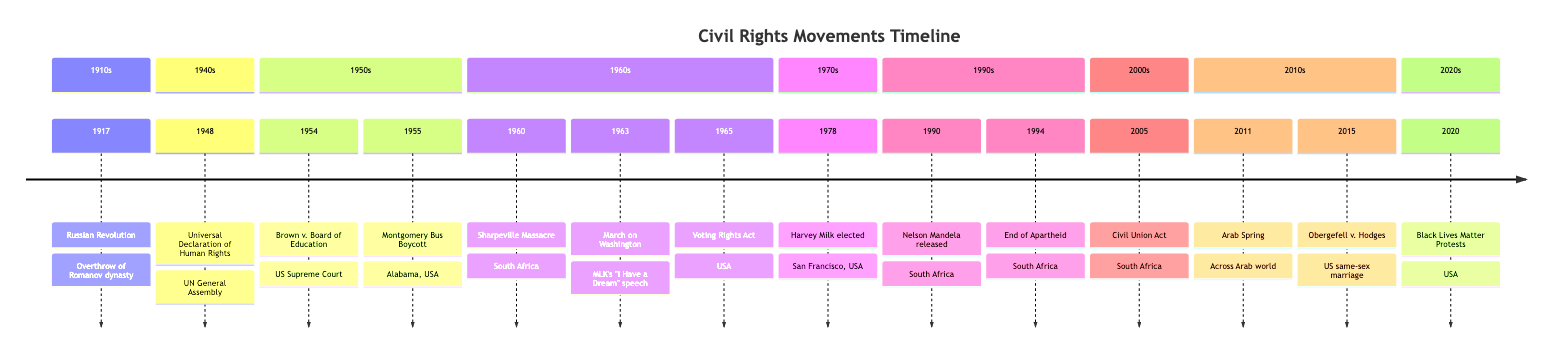What event occurred in 1963? Referring to the timeline, there is a specific node indicating the year 1963, which lists the event "March on Washington for Jobs and Freedom."
Answer: March on Washington for Jobs and Freedom How many major events occurred in the 1950s? By examining the timeline, we can count the events listed under the 1950s section: there are two events, "Brown v. Board of Education" (1954) and "Montgomery Bus Boycott" (1955).
Answer: 2 Which country was associated with the Voting Rights Act? Looking at the node for the Voting Rights Act, there is a label identifying the associated country as the "United States."
Answer: United States What year marked the end of apartheid in South Africa? The timeline indicates that the end of apartheid occurred in the year 1994, as labeled in the corresponding node.
Answer: 1994 Which event is linked to Nelson Mandela's release? A review of the timeline shows that the event titled "Release of Nelson Mandela" in 1990 is directly connected to his subsequent role in the anti-apartheid movement.
Answer: Release of Nelson Mandela What was a pivotal moment in the American Civil Rights Movement? The timeline highlights "March on Washington for Jobs and Freedom" in 1963 as a pivotal event, indicated by Martin Luther King Jr.'s famous speech delivered there.
Answer: March on Washington for Jobs and Freedom Where did the Sharpeville Massacre take place? The timeline specifies that the Sharpeville Massacre occurred in South Africa, as indicated in the event's description for the year 1960.
Answer: South Africa Which event followed the Arab Spring? Analyzing the timeline, the event "Obergefell v. Hodges," occurring in 2015, is positioned right after the Arab Spring that took place in 2011, indicating a subsequent significant moment.
Answer: Obergefell v. Hodges 